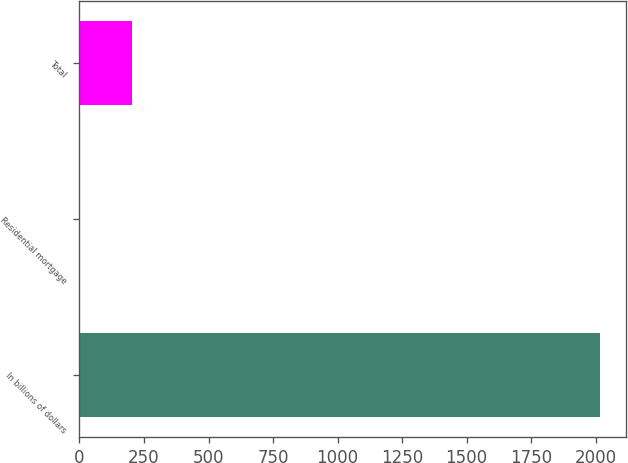Convert chart. <chart><loc_0><loc_0><loc_500><loc_500><bar_chart><fcel>In billions of dollars<fcel>Residential mortgage<fcel>Total<nl><fcel>2017<fcel>0.4<fcel>202.06<nl></chart> 